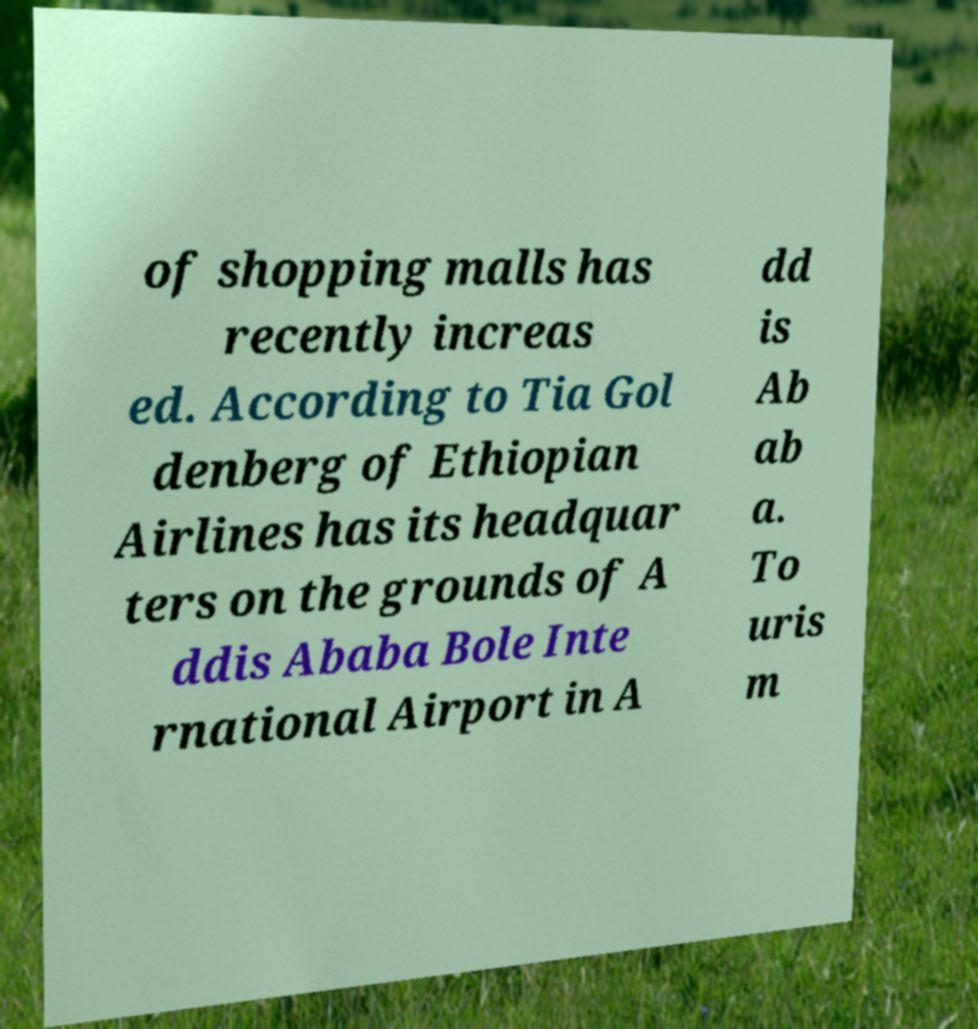Please read and relay the text visible in this image. What does it say? of shopping malls has recently increas ed. According to Tia Gol denberg of Ethiopian Airlines has its headquar ters on the grounds of A ddis Ababa Bole Inte rnational Airport in A dd is Ab ab a. To uris m 